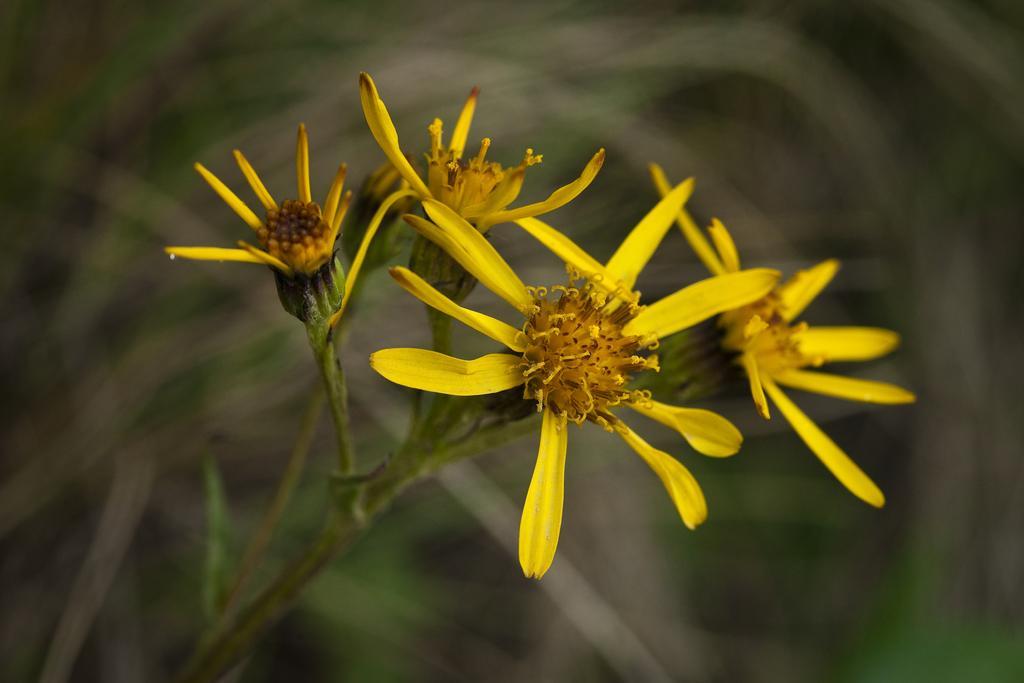How would you summarize this image in a sentence or two? In the image there is a stem with yellow flowers. And there is a blur background. 